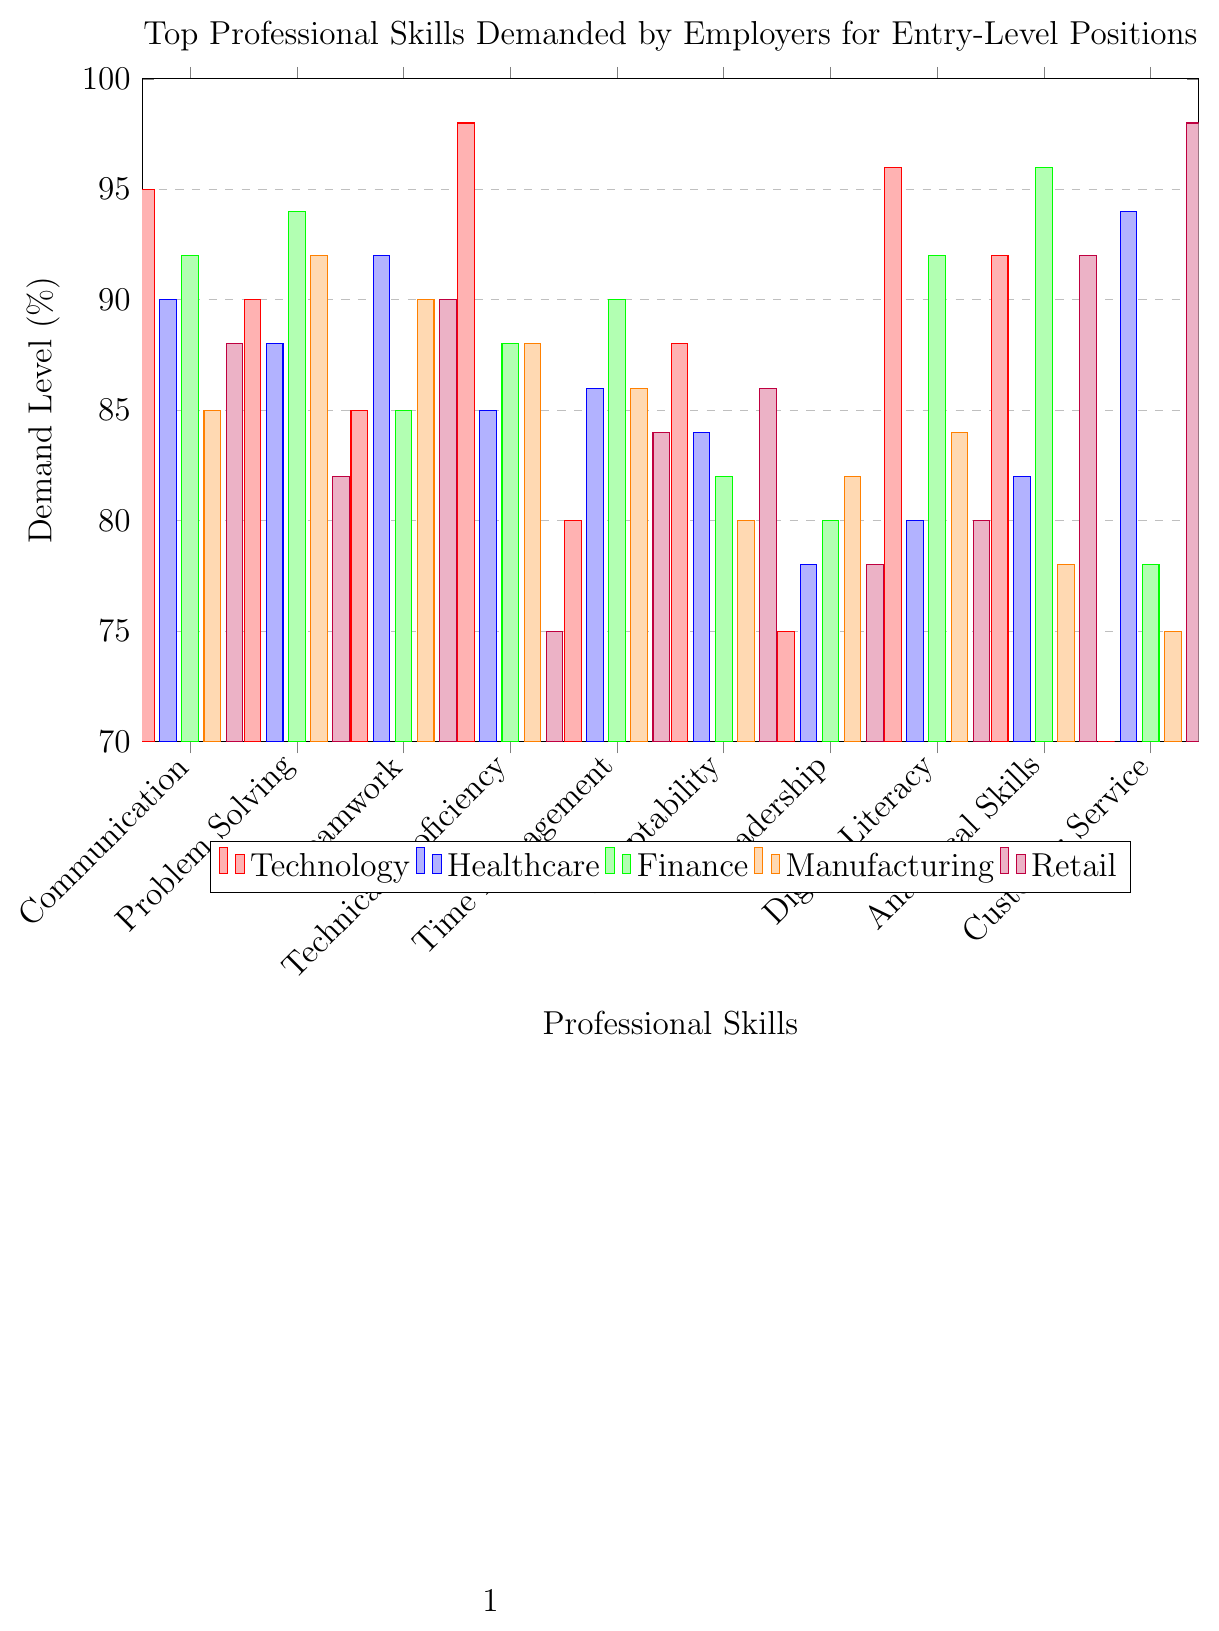Which industry demands Communication skills the most? By examining the heights of the bars for Communication skills, the highest bar corresponds to the Education industry.
Answer: Education What is the average demand level for Problem Solving skills across the Technology and Finance industries? The demand levels of Problem Solving skills are 90% for Technology and 94% for Finance. The average is (90 + 94) / 2 = 92%
Answer: 92% Which skill has the highest demand in the Retail industry? By looking at the tallest bar within the Retail industry's category, Customer Service has the highest demand at 98%.
Answer: Customer Service How does the demand for Teamwork skills in Healthcare compare to that in Manufacturing? The bar for Teamwork skills in Healthcare is higher than that in Manufacturing, indicating Healthcare demands Teamwork skills more (92% vs. 90%).
Answer: Healthcare What is the difference in demand for Technical Proficiency between the Technology and Construction industries? For Technical Proficiency, Technology has a demand of 98% and Construction has 94%. The difference is 98 - 94 = 4%.
Answer: 4% Which industry shows the lowest demand for Leadership skills? The shortest bar for Leadership skills belongs to the Technology industry at 75%.
Answer: Technology Combine the demand levels for Digital Literacy in Marketing and Hospitality. What is the total? The demand levels for Digital Literacy are 94% in Marketing and 82% in Hospitality. The total is 94 + 82 = 176%.
Answer: 176% Is Time Management more in demand in Logistics or Retail? The height of the bar for Time Management in Logistics is 94%, which is greater than the 84% in Retail.
Answer: Logistics What is the median demand level for Customer Service across all industries? The Customer Service demand levels are 70, 94, 78, 75, 98, 92, 88, 98, 76, 80. Sorting these values yields 70, 75, 76, 78, 80, 88, 92, 94, 98, 98. The median values (80 and 88) thus average to (80 + 88) / 2 = 84%.
Answer: 84% Compare the demand for Analytical Skills in Finance with that in Manufacturing. What is the result? Finance has a demand of 96% for Analytical Skills, while Manufacturing has 78%. Finance demands Analytical Skills more (96% > 78%).
Answer: Finance 